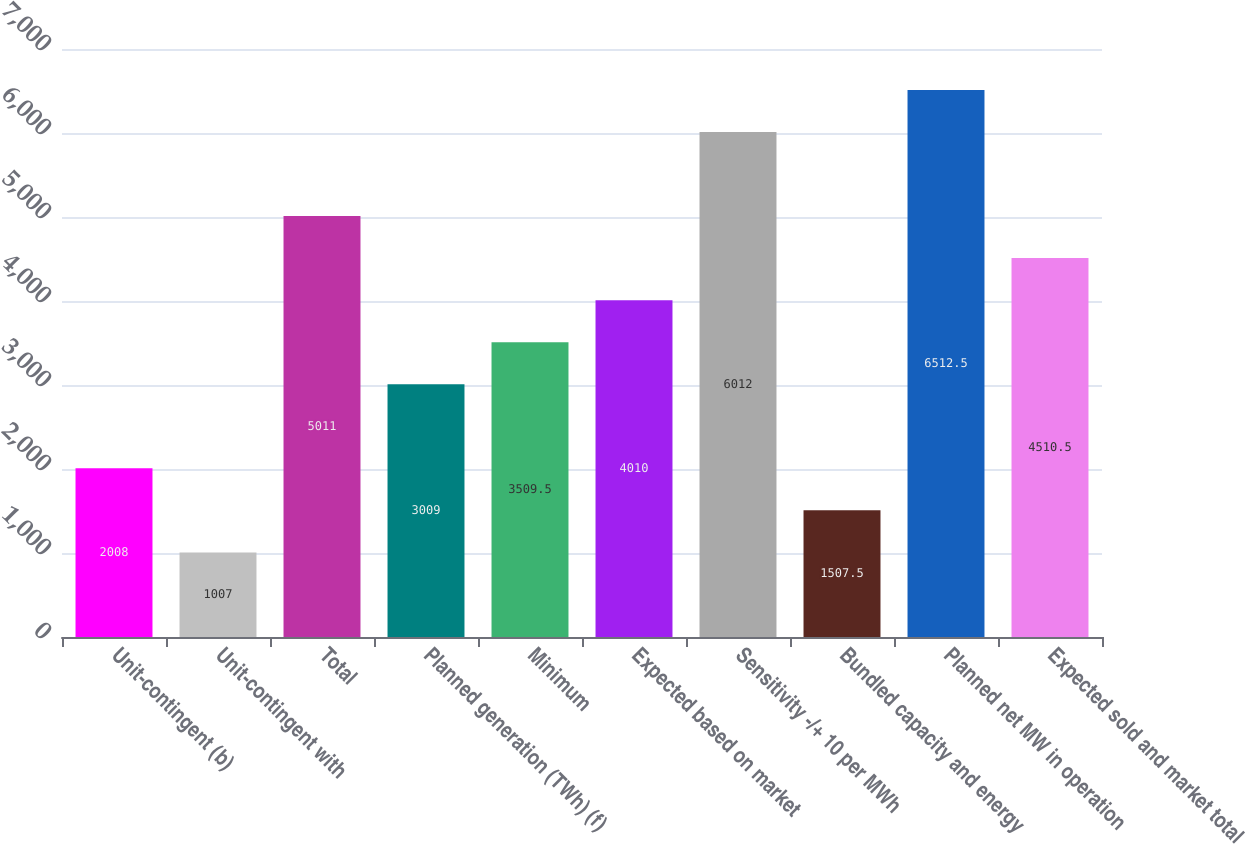Convert chart to OTSL. <chart><loc_0><loc_0><loc_500><loc_500><bar_chart><fcel>Unit-contingent (b)<fcel>Unit-contingent with<fcel>Total<fcel>Planned generation (TWh) (f)<fcel>Minimum<fcel>Expected based on market<fcel>Sensitivity -/+ 10 per MWh<fcel>Bundled capacity and energy<fcel>Planned net MW in operation<fcel>Expected sold and market total<nl><fcel>2008<fcel>1007<fcel>5011<fcel>3009<fcel>3509.5<fcel>4010<fcel>6012<fcel>1507.5<fcel>6512.5<fcel>4510.5<nl></chart> 